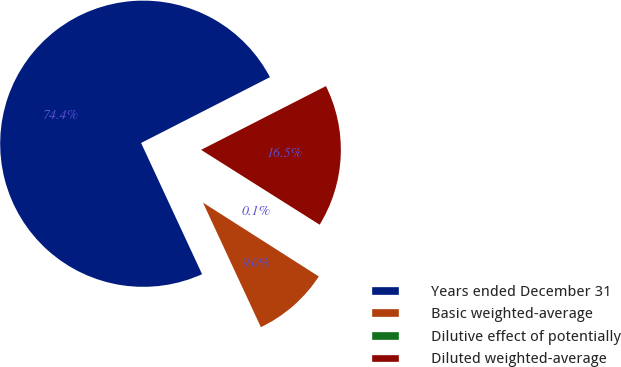<chart> <loc_0><loc_0><loc_500><loc_500><pie_chart><fcel>Years ended December 31<fcel>Basic weighted-average<fcel>Dilutive effect of potentially<fcel>Diluted weighted-average<nl><fcel>74.41%<fcel>9.04%<fcel>0.07%<fcel>16.48%<nl></chart> 